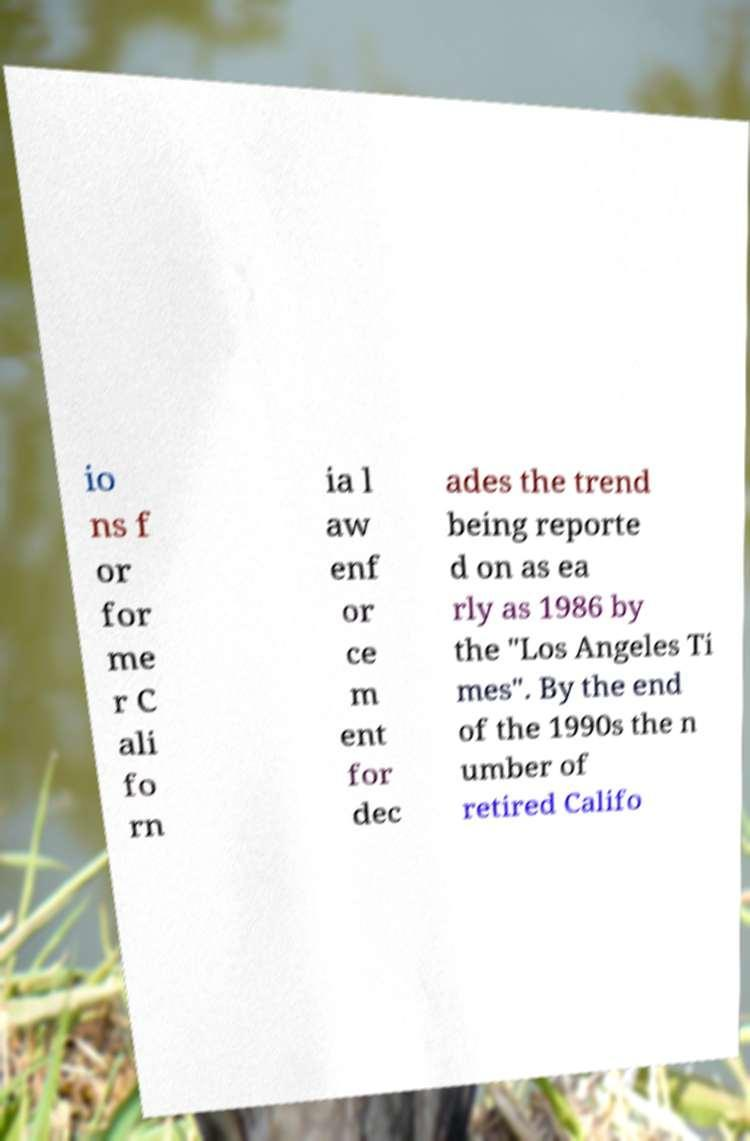There's text embedded in this image that I need extracted. Can you transcribe it verbatim? io ns f or for me r C ali fo rn ia l aw enf or ce m ent for dec ades the trend being reporte d on as ea rly as 1986 by the "Los Angeles Ti mes". By the end of the 1990s the n umber of retired Califo 